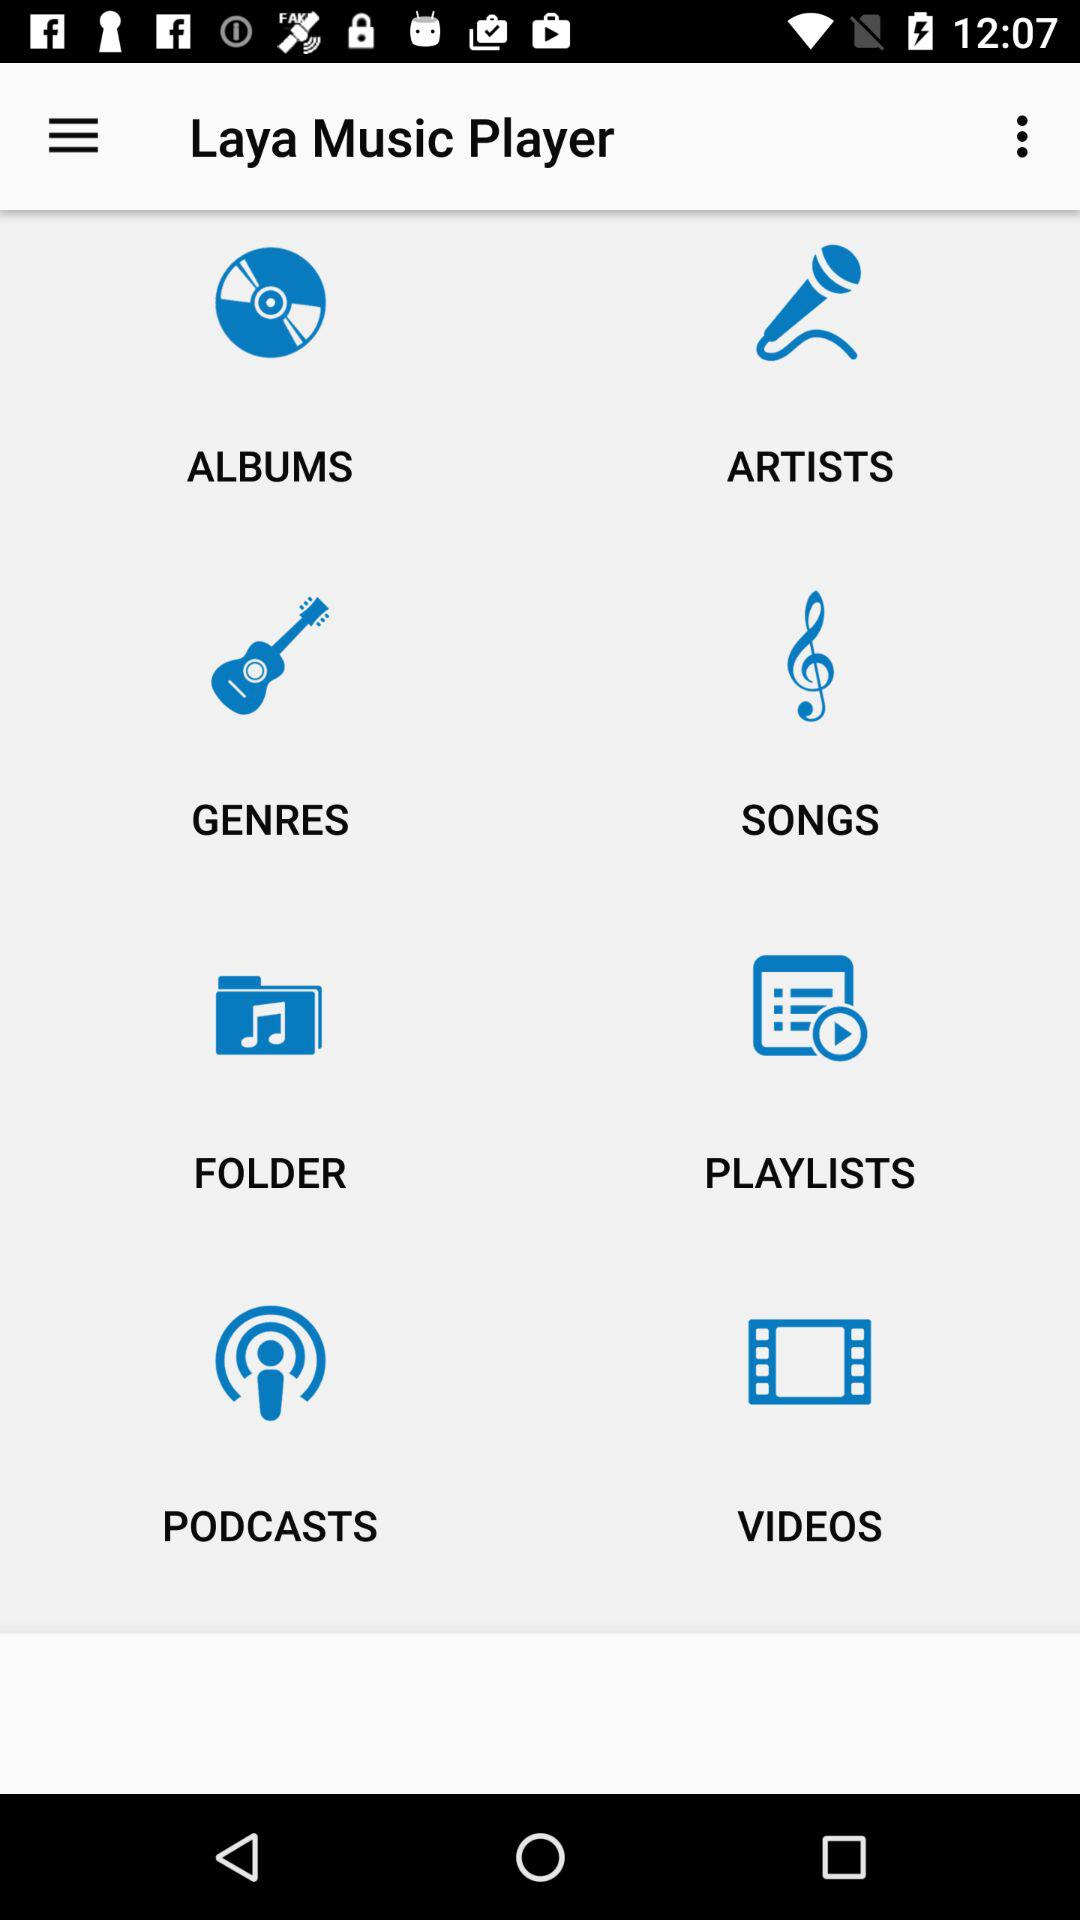What is the application name? The application name is "Laya Music Player". 